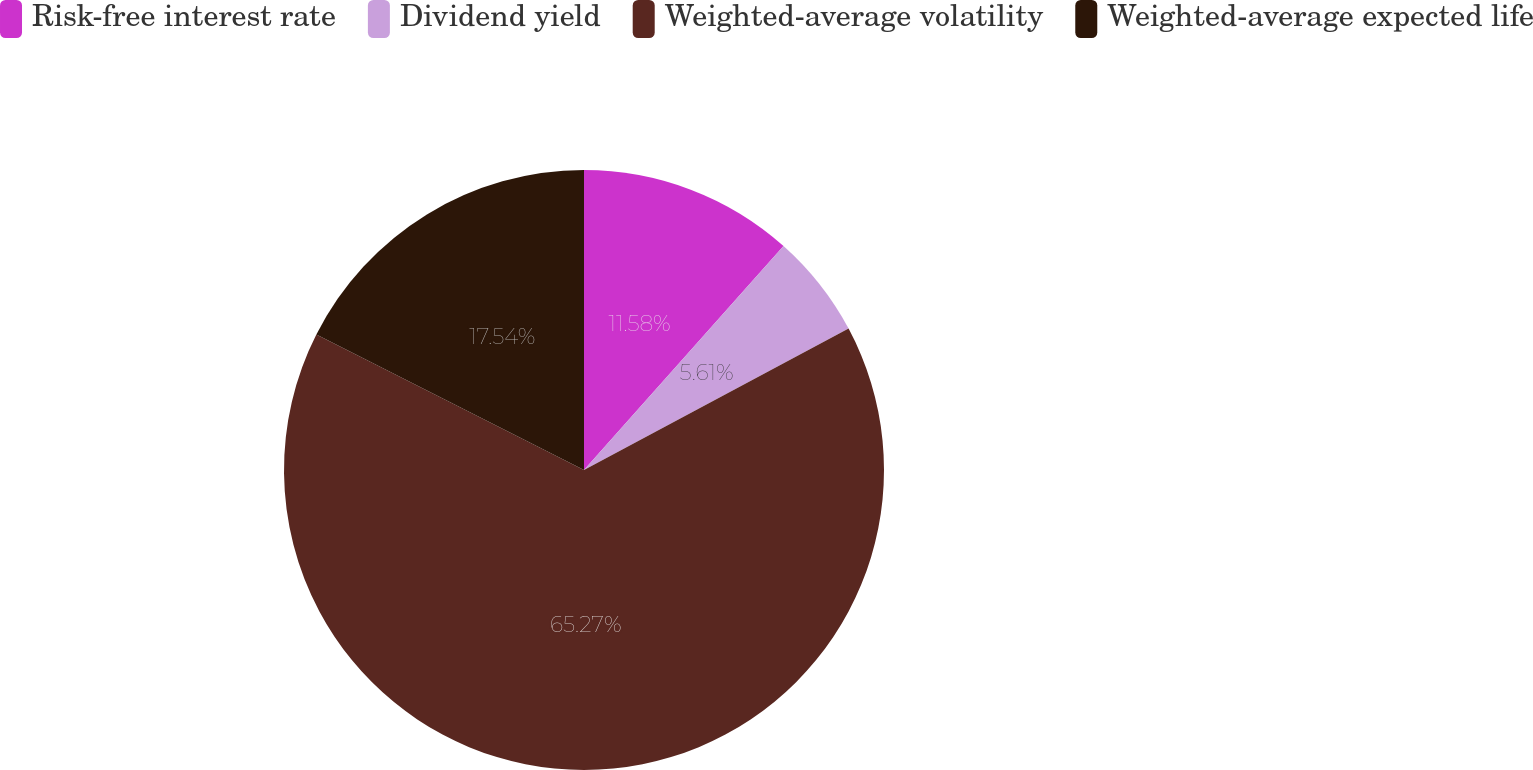<chart> <loc_0><loc_0><loc_500><loc_500><pie_chart><fcel>Risk-free interest rate<fcel>Dividend yield<fcel>Weighted-average volatility<fcel>Weighted-average expected life<nl><fcel>11.58%<fcel>5.61%<fcel>65.27%<fcel>17.54%<nl></chart> 